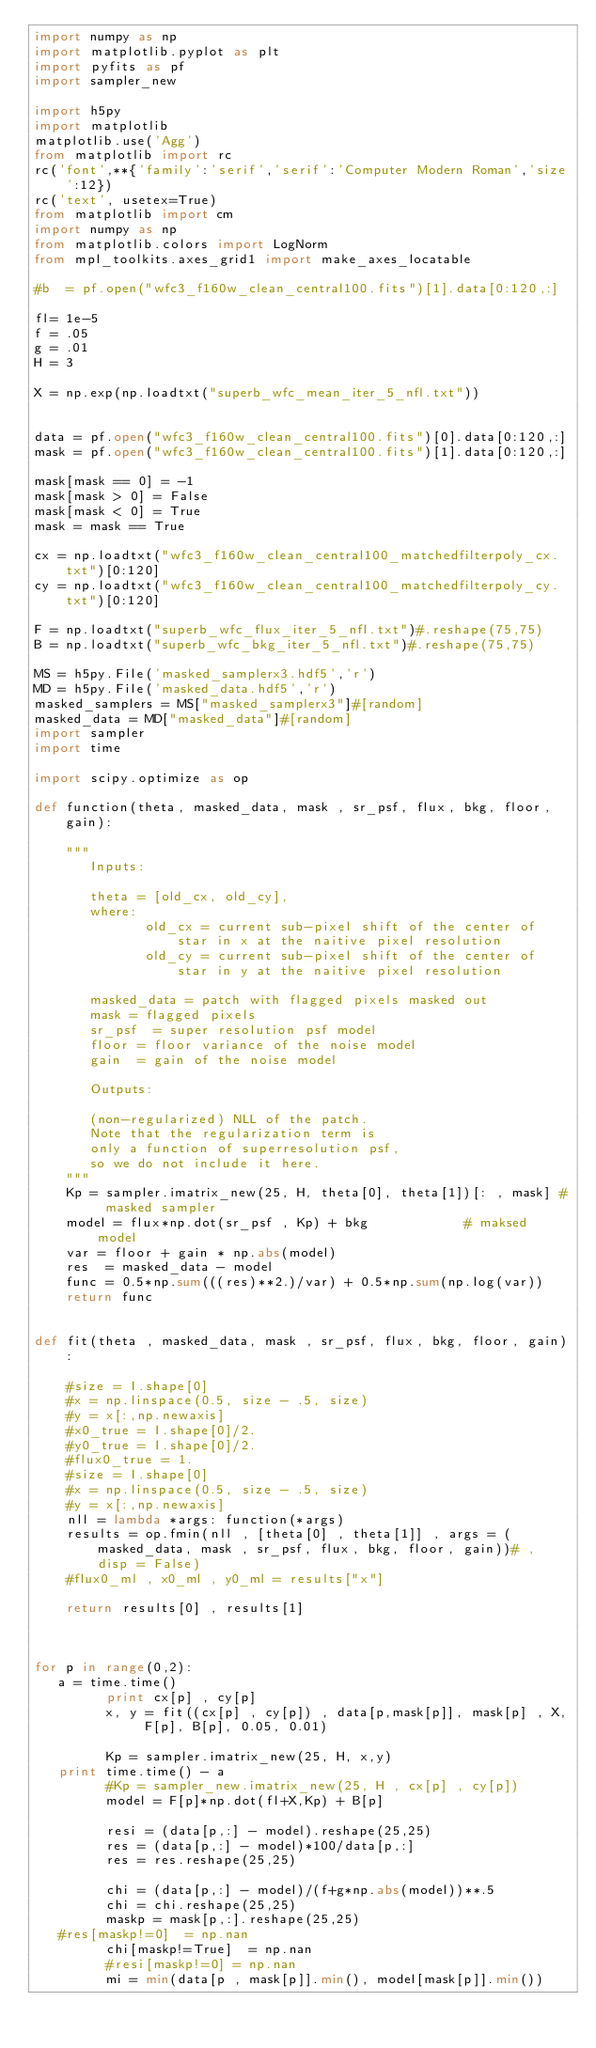<code> <loc_0><loc_0><loc_500><loc_500><_Python_>import numpy as np
import matplotlib.pyplot as plt
import pyfits as pf
import sampler_new

import h5py
import matplotlib
matplotlib.use('Agg')
from matplotlib import rc
rc('font',**{'family':'serif','serif':'Computer Modern Roman','size':12})
rc('text', usetex=True)
from matplotlib import cm
import numpy as np
from matplotlib.colors import LogNorm
from mpl_toolkits.axes_grid1 import make_axes_locatable

#b  = pf.open("wfc3_f160w_clean_central100.fits")[1].data[0:120,:]

fl= 1e-5
f = .05
g = .01 
H = 3

X = np.exp(np.loadtxt("superb_wfc_mean_iter_5_nfl.txt"))


data = pf.open("wfc3_f160w_clean_central100.fits")[0].data[0:120,:]
mask = pf.open("wfc3_f160w_clean_central100.fits")[1].data[0:120,:]

mask[mask == 0] = -1
mask[mask > 0] = False
mask[mask < 0] = True
mask = mask == True

cx = np.loadtxt("wfc3_f160w_clean_central100_matchedfilterpoly_cx.txt")[0:120]
cy = np.loadtxt("wfc3_f160w_clean_central100_matchedfilterpoly_cy.txt")[0:120]

F = np.loadtxt("superb_wfc_flux_iter_5_nfl.txt")#.reshape(75,75)
B = np.loadtxt("superb_wfc_bkg_iter_5_nfl.txt")#.reshape(75,75)

MS = h5py.File('masked_samplerx3.hdf5','r')
MD = h5py.File('masked_data.hdf5','r')
masked_samplers = MS["masked_samplerx3"]#[random]
masked_data = MD["masked_data"]#[random]
import sampler
import time

import scipy.optimize as op

def function(theta, masked_data, mask , sr_psf, flux, bkg, floor, gain):

    """
       Inputs:
    
       theta = [old_cx, old_cy],
       where:
              old_cx = current sub-pixel shift of the center of star in x at the naitive pixel resolution
              old_cy = current sub-pixel shift of the center of star in y at the naitive pixel resolution

       masked_data = patch with flagged pixels masked out
       mask = flagged pixels
       sr_psf  = super resolution psf model
       floor = floor variance of the noise model
       gain  = gain of the noise model

       Outputs:

       (non-regularized) NLL of the patch.
       Note that the regularization term is 
       only a function of superresolution psf, 
       so we do not include it here.
    """
    Kp = sampler.imatrix_new(25, H, theta[0], theta[1])[: , mask] # masked sampler
    model = flux*np.dot(sr_psf , Kp) + bkg            # maksed model
    var = floor + gain * np.abs(model)
    res  = masked_data - model
    func = 0.5*np.sum(((res)**2.)/var) + 0.5*np.sum(np.log(var))
    return func


def fit(theta , masked_data, mask , sr_psf, flux, bkg, floor, gain):
    
    #size = I.shape[0]
    #x = np.linspace(0.5, size - .5, size)
    #y = x[:,np.newaxis]
    #x0_true = I.shape[0]/2.
    #y0_true = I.shape[0]/2.
    #flux0_true = 1.
    #size = I.shape[0]
    #x = np.linspace(0.5, size - .5, size)
    #y = x[:,np.newaxis]
    nll = lambda *args: function(*args)
    results = op.fmin(nll , [theta[0] , theta[1]] , args = (masked_data, mask , sr_psf, flux, bkg, floor, gain))# , disp = False)
    #flux0_ml , x0_ml , y0_ml = results["x"]

    return results[0] , results[1]



for p in range(0,2):
	 a = time.time()
         print cx[p] , cy[p]
         x, y = fit((cx[p] , cy[p]) , data[p,mask[p]], mask[p] , X, F[p], B[p], 0.05, 0.01)
         
         Kp = sampler.imatrix_new(25, H, x,y)
	 print time.time() - a
         #Kp = sampler_new.imatrix_new(25, H , cx[p] , cy[p])
         model = F[p]*np.dot(fl+X,Kp) + B[p]
        
         resi = (data[p,:] - model).reshape(25,25)
         res = (data[p,:] - model)*100/data[p,:]
         res = res.reshape(25,25)
         
         chi = (data[p,:] - model)/(f+g*np.abs(model))**.5
         chi = chi.reshape(25,25)
         maskp = mask[p,:].reshape(25,25)
	 #res[maskp!=0]  = np.nan
         chi[maskp!=True]  = np.nan
         #resi[maskp!=0] = np.nan
         mi = min(data[p , mask[p]].min(), model[mask[p]].min())</code> 